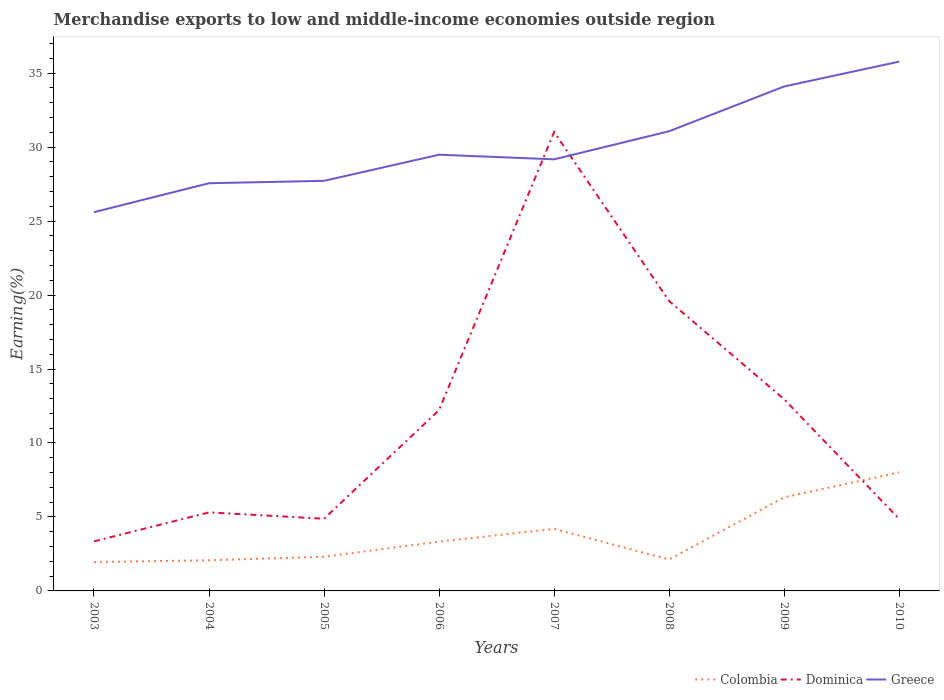How many different coloured lines are there?
Offer a very short reply. 3. Is the number of lines equal to the number of legend labels?
Your response must be concise. Yes. Across all years, what is the maximum percentage of amount earned from merchandise exports in Colombia?
Offer a very short reply. 1.95. In which year was the percentage of amount earned from merchandise exports in Colombia maximum?
Provide a short and direct response. 2003. What is the total percentage of amount earned from merchandise exports in Dominica in the graph?
Keep it short and to the point. -27.67. What is the difference between the highest and the second highest percentage of amount earned from merchandise exports in Greece?
Offer a terse response. 10.18. What is the difference between the highest and the lowest percentage of amount earned from merchandise exports in Colombia?
Your answer should be compact. 3. Is the percentage of amount earned from merchandise exports in Dominica strictly greater than the percentage of amount earned from merchandise exports in Greece over the years?
Provide a succinct answer. No. Are the values on the major ticks of Y-axis written in scientific E-notation?
Your answer should be compact. No. Does the graph contain any zero values?
Your response must be concise. No. Where does the legend appear in the graph?
Make the answer very short. Bottom right. How many legend labels are there?
Keep it short and to the point. 3. How are the legend labels stacked?
Make the answer very short. Horizontal. What is the title of the graph?
Your answer should be very brief. Merchandise exports to low and middle-income economies outside region. What is the label or title of the Y-axis?
Provide a succinct answer. Earning(%). What is the Earning(%) of Colombia in 2003?
Offer a very short reply. 1.95. What is the Earning(%) of Dominica in 2003?
Provide a succinct answer. 3.35. What is the Earning(%) in Greece in 2003?
Provide a short and direct response. 25.6. What is the Earning(%) in Colombia in 2004?
Keep it short and to the point. 2.07. What is the Earning(%) in Dominica in 2004?
Your answer should be compact. 5.31. What is the Earning(%) in Greece in 2004?
Keep it short and to the point. 27.56. What is the Earning(%) in Colombia in 2005?
Your answer should be compact. 2.31. What is the Earning(%) in Dominica in 2005?
Provide a succinct answer. 4.88. What is the Earning(%) in Greece in 2005?
Ensure brevity in your answer.  27.72. What is the Earning(%) of Colombia in 2006?
Offer a very short reply. 3.33. What is the Earning(%) of Dominica in 2006?
Offer a terse response. 12.23. What is the Earning(%) of Greece in 2006?
Provide a succinct answer. 29.48. What is the Earning(%) in Colombia in 2007?
Your answer should be compact. 4.19. What is the Earning(%) of Dominica in 2007?
Your response must be concise. 31.02. What is the Earning(%) in Greece in 2007?
Offer a terse response. 29.17. What is the Earning(%) in Colombia in 2008?
Your answer should be compact. 2.13. What is the Earning(%) of Dominica in 2008?
Give a very brief answer. 19.59. What is the Earning(%) of Greece in 2008?
Keep it short and to the point. 31.07. What is the Earning(%) of Colombia in 2009?
Your answer should be very brief. 6.33. What is the Earning(%) of Dominica in 2009?
Offer a terse response. 12.95. What is the Earning(%) of Greece in 2009?
Your answer should be very brief. 34.1. What is the Earning(%) of Colombia in 2010?
Your answer should be compact. 8.01. What is the Earning(%) of Dominica in 2010?
Make the answer very short. 4.86. What is the Earning(%) of Greece in 2010?
Provide a succinct answer. 35.78. Across all years, what is the maximum Earning(%) of Colombia?
Your answer should be compact. 8.01. Across all years, what is the maximum Earning(%) in Dominica?
Your response must be concise. 31.02. Across all years, what is the maximum Earning(%) in Greece?
Keep it short and to the point. 35.78. Across all years, what is the minimum Earning(%) in Colombia?
Your response must be concise. 1.95. Across all years, what is the minimum Earning(%) of Dominica?
Make the answer very short. 3.35. Across all years, what is the minimum Earning(%) of Greece?
Ensure brevity in your answer.  25.6. What is the total Earning(%) of Colombia in the graph?
Provide a short and direct response. 30.32. What is the total Earning(%) of Dominica in the graph?
Your answer should be very brief. 94.18. What is the total Earning(%) of Greece in the graph?
Your response must be concise. 240.48. What is the difference between the Earning(%) of Colombia in 2003 and that in 2004?
Offer a terse response. -0.12. What is the difference between the Earning(%) of Dominica in 2003 and that in 2004?
Your answer should be very brief. -1.96. What is the difference between the Earning(%) in Greece in 2003 and that in 2004?
Make the answer very short. -1.96. What is the difference between the Earning(%) of Colombia in 2003 and that in 2005?
Your answer should be compact. -0.36. What is the difference between the Earning(%) in Dominica in 2003 and that in 2005?
Provide a succinct answer. -1.53. What is the difference between the Earning(%) in Greece in 2003 and that in 2005?
Your answer should be compact. -2.12. What is the difference between the Earning(%) in Colombia in 2003 and that in 2006?
Provide a short and direct response. -1.38. What is the difference between the Earning(%) in Dominica in 2003 and that in 2006?
Your answer should be compact. -8.88. What is the difference between the Earning(%) of Greece in 2003 and that in 2006?
Give a very brief answer. -3.88. What is the difference between the Earning(%) of Colombia in 2003 and that in 2007?
Provide a succinct answer. -2.24. What is the difference between the Earning(%) of Dominica in 2003 and that in 2007?
Make the answer very short. -27.67. What is the difference between the Earning(%) of Greece in 2003 and that in 2007?
Your answer should be very brief. -3.57. What is the difference between the Earning(%) in Colombia in 2003 and that in 2008?
Your answer should be compact. -0.18. What is the difference between the Earning(%) in Dominica in 2003 and that in 2008?
Make the answer very short. -16.24. What is the difference between the Earning(%) of Greece in 2003 and that in 2008?
Keep it short and to the point. -5.47. What is the difference between the Earning(%) of Colombia in 2003 and that in 2009?
Your answer should be compact. -4.38. What is the difference between the Earning(%) of Dominica in 2003 and that in 2009?
Your answer should be very brief. -9.61. What is the difference between the Earning(%) of Greece in 2003 and that in 2009?
Your answer should be very brief. -8.5. What is the difference between the Earning(%) of Colombia in 2003 and that in 2010?
Make the answer very short. -6.06. What is the difference between the Earning(%) of Dominica in 2003 and that in 2010?
Make the answer very short. -1.52. What is the difference between the Earning(%) in Greece in 2003 and that in 2010?
Your answer should be very brief. -10.18. What is the difference between the Earning(%) in Colombia in 2004 and that in 2005?
Give a very brief answer. -0.24. What is the difference between the Earning(%) of Dominica in 2004 and that in 2005?
Make the answer very short. 0.43. What is the difference between the Earning(%) of Greece in 2004 and that in 2005?
Your response must be concise. -0.16. What is the difference between the Earning(%) in Colombia in 2004 and that in 2006?
Your answer should be compact. -1.26. What is the difference between the Earning(%) of Dominica in 2004 and that in 2006?
Your answer should be compact. -6.92. What is the difference between the Earning(%) in Greece in 2004 and that in 2006?
Give a very brief answer. -1.93. What is the difference between the Earning(%) in Colombia in 2004 and that in 2007?
Your response must be concise. -2.12. What is the difference between the Earning(%) of Dominica in 2004 and that in 2007?
Your answer should be compact. -25.71. What is the difference between the Earning(%) of Greece in 2004 and that in 2007?
Keep it short and to the point. -1.62. What is the difference between the Earning(%) in Colombia in 2004 and that in 2008?
Give a very brief answer. -0.06. What is the difference between the Earning(%) in Dominica in 2004 and that in 2008?
Your answer should be compact. -14.28. What is the difference between the Earning(%) of Greece in 2004 and that in 2008?
Keep it short and to the point. -3.51. What is the difference between the Earning(%) in Colombia in 2004 and that in 2009?
Provide a succinct answer. -4.26. What is the difference between the Earning(%) of Dominica in 2004 and that in 2009?
Provide a succinct answer. -7.64. What is the difference between the Earning(%) in Greece in 2004 and that in 2009?
Provide a succinct answer. -6.54. What is the difference between the Earning(%) of Colombia in 2004 and that in 2010?
Offer a terse response. -5.94. What is the difference between the Earning(%) in Dominica in 2004 and that in 2010?
Make the answer very short. 0.45. What is the difference between the Earning(%) in Greece in 2004 and that in 2010?
Ensure brevity in your answer.  -8.22. What is the difference between the Earning(%) of Colombia in 2005 and that in 2006?
Keep it short and to the point. -1.02. What is the difference between the Earning(%) in Dominica in 2005 and that in 2006?
Your answer should be very brief. -7.35. What is the difference between the Earning(%) in Greece in 2005 and that in 2006?
Offer a very short reply. -1.77. What is the difference between the Earning(%) of Colombia in 2005 and that in 2007?
Ensure brevity in your answer.  -1.88. What is the difference between the Earning(%) of Dominica in 2005 and that in 2007?
Your answer should be very brief. -26.14. What is the difference between the Earning(%) of Greece in 2005 and that in 2007?
Provide a short and direct response. -1.45. What is the difference between the Earning(%) in Colombia in 2005 and that in 2008?
Ensure brevity in your answer.  0.18. What is the difference between the Earning(%) in Dominica in 2005 and that in 2008?
Provide a succinct answer. -14.71. What is the difference between the Earning(%) of Greece in 2005 and that in 2008?
Your answer should be compact. -3.35. What is the difference between the Earning(%) of Colombia in 2005 and that in 2009?
Provide a short and direct response. -4.02. What is the difference between the Earning(%) of Dominica in 2005 and that in 2009?
Offer a terse response. -8.07. What is the difference between the Earning(%) of Greece in 2005 and that in 2009?
Give a very brief answer. -6.38. What is the difference between the Earning(%) of Colombia in 2005 and that in 2010?
Offer a terse response. -5.7. What is the difference between the Earning(%) of Dominica in 2005 and that in 2010?
Your answer should be compact. 0.02. What is the difference between the Earning(%) in Greece in 2005 and that in 2010?
Your answer should be very brief. -8.06. What is the difference between the Earning(%) of Colombia in 2006 and that in 2007?
Keep it short and to the point. -0.86. What is the difference between the Earning(%) in Dominica in 2006 and that in 2007?
Make the answer very short. -18.79. What is the difference between the Earning(%) of Greece in 2006 and that in 2007?
Offer a terse response. 0.31. What is the difference between the Earning(%) of Colombia in 2006 and that in 2008?
Your answer should be very brief. 1.2. What is the difference between the Earning(%) of Dominica in 2006 and that in 2008?
Your answer should be compact. -7.36. What is the difference between the Earning(%) of Greece in 2006 and that in 2008?
Your answer should be compact. -1.59. What is the difference between the Earning(%) of Colombia in 2006 and that in 2009?
Give a very brief answer. -3. What is the difference between the Earning(%) in Dominica in 2006 and that in 2009?
Provide a short and direct response. -0.73. What is the difference between the Earning(%) of Greece in 2006 and that in 2009?
Offer a very short reply. -4.61. What is the difference between the Earning(%) in Colombia in 2006 and that in 2010?
Provide a succinct answer. -4.68. What is the difference between the Earning(%) of Dominica in 2006 and that in 2010?
Your answer should be compact. 7.36. What is the difference between the Earning(%) in Greece in 2006 and that in 2010?
Keep it short and to the point. -6.29. What is the difference between the Earning(%) of Colombia in 2007 and that in 2008?
Provide a short and direct response. 2.06. What is the difference between the Earning(%) in Dominica in 2007 and that in 2008?
Make the answer very short. 11.43. What is the difference between the Earning(%) in Greece in 2007 and that in 2008?
Keep it short and to the point. -1.9. What is the difference between the Earning(%) in Colombia in 2007 and that in 2009?
Provide a short and direct response. -2.14. What is the difference between the Earning(%) in Dominica in 2007 and that in 2009?
Provide a succinct answer. 18.06. What is the difference between the Earning(%) in Greece in 2007 and that in 2009?
Provide a short and direct response. -4.93. What is the difference between the Earning(%) of Colombia in 2007 and that in 2010?
Ensure brevity in your answer.  -3.82. What is the difference between the Earning(%) of Dominica in 2007 and that in 2010?
Keep it short and to the point. 26.15. What is the difference between the Earning(%) in Greece in 2007 and that in 2010?
Offer a very short reply. -6.61. What is the difference between the Earning(%) of Colombia in 2008 and that in 2009?
Provide a short and direct response. -4.2. What is the difference between the Earning(%) of Dominica in 2008 and that in 2009?
Offer a very short reply. 6.64. What is the difference between the Earning(%) in Greece in 2008 and that in 2009?
Ensure brevity in your answer.  -3.03. What is the difference between the Earning(%) in Colombia in 2008 and that in 2010?
Ensure brevity in your answer.  -5.88. What is the difference between the Earning(%) of Dominica in 2008 and that in 2010?
Give a very brief answer. 14.73. What is the difference between the Earning(%) in Greece in 2008 and that in 2010?
Your answer should be compact. -4.71. What is the difference between the Earning(%) of Colombia in 2009 and that in 2010?
Your answer should be very brief. -1.68. What is the difference between the Earning(%) in Dominica in 2009 and that in 2010?
Offer a very short reply. 8.09. What is the difference between the Earning(%) of Greece in 2009 and that in 2010?
Offer a very short reply. -1.68. What is the difference between the Earning(%) in Colombia in 2003 and the Earning(%) in Dominica in 2004?
Make the answer very short. -3.36. What is the difference between the Earning(%) in Colombia in 2003 and the Earning(%) in Greece in 2004?
Offer a very short reply. -25.61. What is the difference between the Earning(%) in Dominica in 2003 and the Earning(%) in Greece in 2004?
Your answer should be very brief. -24.21. What is the difference between the Earning(%) in Colombia in 2003 and the Earning(%) in Dominica in 2005?
Offer a very short reply. -2.93. What is the difference between the Earning(%) of Colombia in 2003 and the Earning(%) of Greece in 2005?
Provide a short and direct response. -25.77. What is the difference between the Earning(%) of Dominica in 2003 and the Earning(%) of Greece in 2005?
Your response must be concise. -24.37. What is the difference between the Earning(%) in Colombia in 2003 and the Earning(%) in Dominica in 2006?
Give a very brief answer. -10.28. What is the difference between the Earning(%) in Colombia in 2003 and the Earning(%) in Greece in 2006?
Keep it short and to the point. -27.53. What is the difference between the Earning(%) in Dominica in 2003 and the Earning(%) in Greece in 2006?
Give a very brief answer. -26.14. What is the difference between the Earning(%) of Colombia in 2003 and the Earning(%) of Dominica in 2007?
Offer a terse response. -29.07. What is the difference between the Earning(%) of Colombia in 2003 and the Earning(%) of Greece in 2007?
Offer a terse response. -27.22. What is the difference between the Earning(%) of Dominica in 2003 and the Earning(%) of Greece in 2007?
Offer a terse response. -25.83. What is the difference between the Earning(%) of Colombia in 2003 and the Earning(%) of Dominica in 2008?
Ensure brevity in your answer.  -17.64. What is the difference between the Earning(%) in Colombia in 2003 and the Earning(%) in Greece in 2008?
Keep it short and to the point. -29.12. What is the difference between the Earning(%) of Dominica in 2003 and the Earning(%) of Greece in 2008?
Your answer should be very brief. -27.72. What is the difference between the Earning(%) in Colombia in 2003 and the Earning(%) in Dominica in 2009?
Offer a terse response. -11. What is the difference between the Earning(%) of Colombia in 2003 and the Earning(%) of Greece in 2009?
Make the answer very short. -32.15. What is the difference between the Earning(%) in Dominica in 2003 and the Earning(%) in Greece in 2009?
Your answer should be very brief. -30.75. What is the difference between the Earning(%) in Colombia in 2003 and the Earning(%) in Dominica in 2010?
Your response must be concise. -2.91. What is the difference between the Earning(%) in Colombia in 2003 and the Earning(%) in Greece in 2010?
Give a very brief answer. -33.83. What is the difference between the Earning(%) of Dominica in 2003 and the Earning(%) of Greece in 2010?
Ensure brevity in your answer.  -32.43. What is the difference between the Earning(%) of Colombia in 2004 and the Earning(%) of Dominica in 2005?
Offer a very short reply. -2.81. What is the difference between the Earning(%) of Colombia in 2004 and the Earning(%) of Greece in 2005?
Your response must be concise. -25.65. What is the difference between the Earning(%) of Dominica in 2004 and the Earning(%) of Greece in 2005?
Your answer should be compact. -22.41. What is the difference between the Earning(%) of Colombia in 2004 and the Earning(%) of Dominica in 2006?
Provide a short and direct response. -10.15. What is the difference between the Earning(%) of Colombia in 2004 and the Earning(%) of Greece in 2006?
Keep it short and to the point. -27.41. What is the difference between the Earning(%) of Dominica in 2004 and the Earning(%) of Greece in 2006?
Offer a terse response. -24.18. What is the difference between the Earning(%) of Colombia in 2004 and the Earning(%) of Dominica in 2007?
Make the answer very short. -28.95. What is the difference between the Earning(%) in Colombia in 2004 and the Earning(%) in Greece in 2007?
Provide a succinct answer. -27.1. What is the difference between the Earning(%) of Dominica in 2004 and the Earning(%) of Greece in 2007?
Your response must be concise. -23.86. What is the difference between the Earning(%) in Colombia in 2004 and the Earning(%) in Dominica in 2008?
Keep it short and to the point. -17.52. What is the difference between the Earning(%) of Colombia in 2004 and the Earning(%) of Greece in 2008?
Give a very brief answer. -29. What is the difference between the Earning(%) of Dominica in 2004 and the Earning(%) of Greece in 2008?
Make the answer very short. -25.76. What is the difference between the Earning(%) in Colombia in 2004 and the Earning(%) in Dominica in 2009?
Offer a very short reply. -10.88. What is the difference between the Earning(%) of Colombia in 2004 and the Earning(%) of Greece in 2009?
Keep it short and to the point. -32.03. What is the difference between the Earning(%) of Dominica in 2004 and the Earning(%) of Greece in 2009?
Your answer should be very brief. -28.79. What is the difference between the Earning(%) in Colombia in 2004 and the Earning(%) in Dominica in 2010?
Offer a very short reply. -2.79. What is the difference between the Earning(%) of Colombia in 2004 and the Earning(%) of Greece in 2010?
Ensure brevity in your answer.  -33.71. What is the difference between the Earning(%) in Dominica in 2004 and the Earning(%) in Greece in 2010?
Your answer should be very brief. -30.47. What is the difference between the Earning(%) of Colombia in 2005 and the Earning(%) of Dominica in 2006?
Offer a terse response. -9.92. What is the difference between the Earning(%) in Colombia in 2005 and the Earning(%) in Greece in 2006?
Offer a terse response. -27.18. What is the difference between the Earning(%) in Dominica in 2005 and the Earning(%) in Greece in 2006?
Make the answer very short. -24.61. What is the difference between the Earning(%) of Colombia in 2005 and the Earning(%) of Dominica in 2007?
Ensure brevity in your answer.  -28.71. What is the difference between the Earning(%) of Colombia in 2005 and the Earning(%) of Greece in 2007?
Provide a short and direct response. -26.86. What is the difference between the Earning(%) in Dominica in 2005 and the Earning(%) in Greece in 2007?
Ensure brevity in your answer.  -24.29. What is the difference between the Earning(%) in Colombia in 2005 and the Earning(%) in Dominica in 2008?
Keep it short and to the point. -17.28. What is the difference between the Earning(%) of Colombia in 2005 and the Earning(%) of Greece in 2008?
Your answer should be compact. -28.76. What is the difference between the Earning(%) in Dominica in 2005 and the Earning(%) in Greece in 2008?
Your answer should be compact. -26.19. What is the difference between the Earning(%) of Colombia in 2005 and the Earning(%) of Dominica in 2009?
Make the answer very short. -10.64. What is the difference between the Earning(%) in Colombia in 2005 and the Earning(%) in Greece in 2009?
Your response must be concise. -31.79. What is the difference between the Earning(%) in Dominica in 2005 and the Earning(%) in Greece in 2009?
Give a very brief answer. -29.22. What is the difference between the Earning(%) of Colombia in 2005 and the Earning(%) of Dominica in 2010?
Your answer should be compact. -2.55. What is the difference between the Earning(%) of Colombia in 2005 and the Earning(%) of Greece in 2010?
Make the answer very short. -33.47. What is the difference between the Earning(%) of Dominica in 2005 and the Earning(%) of Greece in 2010?
Your answer should be compact. -30.9. What is the difference between the Earning(%) in Colombia in 2006 and the Earning(%) in Dominica in 2007?
Offer a very short reply. -27.69. What is the difference between the Earning(%) in Colombia in 2006 and the Earning(%) in Greece in 2007?
Offer a terse response. -25.84. What is the difference between the Earning(%) in Dominica in 2006 and the Earning(%) in Greece in 2007?
Make the answer very short. -16.95. What is the difference between the Earning(%) in Colombia in 2006 and the Earning(%) in Dominica in 2008?
Offer a terse response. -16.26. What is the difference between the Earning(%) in Colombia in 2006 and the Earning(%) in Greece in 2008?
Keep it short and to the point. -27.74. What is the difference between the Earning(%) in Dominica in 2006 and the Earning(%) in Greece in 2008?
Your answer should be compact. -18.85. What is the difference between the Earning(%) in Colombia in 2006 and the Earning(%) in Dominica in 2009?
Provide a succinct answer. -9.62. What is the difference between the Earning(%) in Colombia in 2006 and the Earning(%) in Greece in 2009?
Your answer should be compact. -30.77. What is the difference between the Earning(%) of Dominica in 2006 and the Earning(%) of Greece in 2009?
Provide a succinct answer. -21.87. What is the difference between the Earning(%) in Colombia in 2006 and the Earning(%) in Dominica in 2010?
Your answer should be compact. -1.53. What is the difference between the Earning(%) in Colombia in 2006 and the Earning(%) in Greece in 2010?
Your response must be concise. -32.45. What is the difference between the Earning(%) in Dominica in 2006 and the Earning(%) in Greece in 2010?
Give a very brief answer. -23.55. What is the difference between the Earning(%) in Colombia in 2007 and the Earning(%) in Dominica in 2008?
Your answer should be compact. -15.4. What is the difference between the Earning(%) in Colombia in 2007 and the Earning(%) in Greece in 2008?
Offer a terse response. -26.88. What is the difference between the Earning(%) in Dominica in 2007 and the Earning(%) in Greece in 2008?
Give a very brief answer. -0.05. What is the difference between the Earning(%) of Colombia in 2007 and the Earning(%) of Dominica in 2009?
Keep it short and to the point. -8.76. What is the difference between the Earning(%) of Colombia in 2007 and the Earning(%) of Greece in 2009?
Your response must be concise. -29.91. What is the difference between the Earning(%) of Dominica in 2007 and the Earning(%) of Greece in 2009?
Your answer should be very brief. -3.08. What is the difference between the Earning(%) in Colombia in 2007 and the Earning(%) in Dominica in 2010?
Offer a terse response. -0.67. What is the difference between the Earning(%) in Colombia in 2007 and the Earning(%) in Greece in 2010?
Make the answer very short. -31.59. What is the difference between the Earning(%) in Dominica in 2007 and the Earning(%) in Greece in 2010?
Provide a short and direct response. -4.76. What is the difference between the Earning(%) in Colombia in 2008 and the Earning(%) in Dominica in 2009?
Offer a very short reply. -10.82. What is the difference between the Earning(%) in Colombia in 2008 and the Earning(%) in Greece in 2009?
Your answer should be compact. -31.97. What is the difference between the Earning(%) of Dominica in 2008 and the Earning(%) of Greece in 2009?
Your response must be concise. -14.51. What is the difference between the Earning(%) in Colombia in 2008 and the Earning(%) in Dominica in 2010?
Offer a very short reply. -2.73. What is the difference between the Earning(%) in Colombia in 2008 and the Earning(%) in Greece in 2010?
Keep it short and to the point. -33.65. What is the difference between the Earning(%) in Dominica in 2008 and the Earning(%) in Greece in 2010?
Offer a terse response. -16.19. What is the difference between the Earning(%) of Colombia in 2009 and the Earning(%) of Dominica in 2010?
Your response must be concise. 1.47. What is the difference between the Earning(%) of Colombia in 2009 and the Earning(%) of Greece in 2010?
Your response must be concise. -29.45. What is the difference between the Earning(%) of Dominica in 2009 and the Earning(%) of Greece in 2010?
Ensure brevity in your answer.  -22.83. What is the average Earning(%) in Colombia per year?
Offer a very short reply. 3.79. What is the average Earning(%) of Dominica per year?
Provide a succinct answer. 11.77. What is the average Earning(%) of Greece per year?
Your answer should be compact. 30.06. In the year 2003, what is the difference between the Earning(%) in Colombia and Earning(%) in Dominica?
Keep it short and to the point. -1.4. In the year 2003, what is the difference between the Earning(%) of Colombia and Earning(%) of Greece?
Provide a succinct answer. -23.65. In the year 2003, what is the difference between the Earning(%) in Dominica and Earning(%) in Greece?
Your response must be concise. -22.25. In the year 2004, what is the difference between the Earning(%) of Colombia and Earning(%) of Dominica?
Keep it short and to the point. -3.24. In the year 2004, what is the difference between the Earning(%) in Colombia and Earning(%) in Greece?
Offer a very short reply. -25.49. In the year 2004, what is the difference between the Earning(%) in Dominica and Earning(%) in Greece?
Provide a succinct answer. -22.25. In the year 2005, what is the difference between the Earning(%) in Colombia and Earning(%) in Dominica?
Your answer should be compact. -2.57. In the year 2005, what is the difference between the Earning(%) in Colombia and Earning(%) in Greece?
Your response must be concise. -25.41. In the year 2005, what is the difference between the Earning(%) in Dominica and Earning(%) in Greece?
Give a very brief answer. -22.84. In the year 2006, what is the difference between the Earning(%) of Colombia and Earning(%) of Dominica?
Ensure brevity in your answer.  -8.89. In the year 2006, what is the difference between the Earning(%) of Colombia and Earning(%) of Greece?
Provide a short and direct response. -26.15. In the year 2006, what is the difference between the Earning(%) of Dominica and Earning(%) of Greece?
Ensure brevity in your answer.  -17.26. In the year 2007, what is the difference between the Earning(%) in Colombia and Earning(%) in Dominica?
Make the answer very short. -26.82. In the year 2007, what is the difference between the Earning(%) of Colombia and Earning(%) of Greece?
Provide a short and direct response. -24.98. In the year 2007, what is the difference between the Earning(%) in Dominica and Earning(%) in Greece?
Offer a very short reply. 1.84. In the year 2008, what is the difference between the Earning(%) in Colombia and Earning(%) in Dominica?
Your answer should be very brief. -17.46. In the year 2008, what is the difference between the Earning(%) in Colombia and Earning(%) in Greece?
Keep it short and to the point. -28.94. In the year 2008, what is the difference between the Earning(%) of Dominica and Earning(%) of Greece?
Your answer should be compact. -11.48. In the year 2009, what is the difference between the Earning(%) in Colombia and Earning(%) in Dominica?
Offer a terse response. -6.62. In the year 2009, what is the difference between the Earning(%) of Colombia and Earning(%) of Greece?
Ensure brevity in your answer.  -27.77. In the year 2009, what is the difference between the Earning(%) in Dominica and Earning(%) in Greece?
Give a very brief answer. -21.15. In the year 2010, what is the difference between the Earning(%) of Colombia and Earning(%) of Dominica?
Keep it short and to the point. 3.15. In the year 2010, what is the difference between the Earning(%) in Colombia and Earning(%) in Greece?
Provide a short and direct response. -27.77. In the year 2010, what is the difference between the Earning(%) of Dominica and Earning(%) of Greece?
Keep it short and to the point. -30.92. What is the ratio of the Earning(%) of Colombia in 2003 to that in 2004?
Offer a terse response. 0.94. What is the ratio of the Earning(%) in Dominica in 2003 to that in 2004?
Your response must be concise. 0.63. What is the ratio of the Earning(%) of Greece in 2003 to that in 2004?
Make the answer very short. 0.93. What is the ratio of the Earning(%) in Colombia in 2003 to that in 2005?
Your answer should be compact. 0.84. What is the ratio of the Earning(%) in Dominica in 2003 to that in 2005?
Your answer should be very brief. 0.69. What is the ratio of the Earning(%) of Greece in 2003 to that in 2005?
Give a very brief answer. 0.92. What is the ratio of the Earning(%) of Colombia in 2003 to that in 2006?
Your answer should be compact. 0.59. What is the ratio of the Earning(%) of Dominica in 2003 to that in 2006?
Offer a terse response. 0.27. What is the ratio of the Earning(%) in Greece in 2003 to that in 2006?
Your response must be concise. 0.87. What is the ratio of the Earning(%) in Colombia in 2003 to that in 2007?
Provide a short and direct response. 0.47. What is the ratio of the Earning(%) in Dominica in 2003 to that in 2007?
Ensure brevity in your answer.  0.11. What is the ratio of the Earning(%) in Greece in 2003 to that in 2007?
Your answer should be compact. 0.88. What is the ratio of the Earning(%) of Colombia in 2003 to that in 2008?
Offer a very short reply. 0.92. What is the ratio of the Earning(%) in Dominica in 2003 to that in 2008?
Offer a terse response. 0.17. What is the ratio of the Earning(%) of Greece in 2003 to that in 2008?
Your response must be concise. 0.82. What is the ratio of the Earning(%) in Colombia in 2003 to that in 2009?
Provide a short and direct response. 0.31. What is the ratio of the Earning(%) of Dominica in 2003 to that in 2009?
Keep it short and to the point. 0.26. What is the ratio of the Earning(%) in Greece in 2003 to that in 2009?
Provide a succinct answer. 0.75. What is the ratio of the Earning(%) in Colombia in 2003 to that in 2010?
Provide a short and direct response. 0.24. What is the ratio of the Earning(%) in Dominica in 2003 to that in 2010?
Keep it short and to the point. 0.69. What is the ratio of the Earning(%) of Greece in 2003 to that in 2010?
Make the answer very short. 0.72. What is the ratio of the Earning(%) of Colombia in 2004 to that in 2005?
Your response must be concise. 0.9. What is the ratio of the Earning(%) of Dominica in 2004 to that in 2005?
Your answer should be very brief. 1.09. What is the ratio of the Earning(%) in Greece in 2004 to that in 2005?
Make the answer very short. 0.99. What is the ratio of the Earning(%) of Colombia in 2004 to that in 2006?
Keep it short and to the point. 0.62. What is the ratio of the Earning(%) in Dominica in 2004 to that in 2006?
Your answer should be compact. 0.43. What is the ratio of the Earning(%) in Greece in 2004 to that in 2006?
Keep it short and to the point. 0.93. What is the ratio of the Earning(%) of Colombia in 2004 to that in 2007?
Offer a very short reply. 0.49. What is the ratio of the Earning(%) of Dominica in 2004 to that in 2007?
Your answer should be compact. 0.17. What is the ratio of the Earning(%) in Greece in 2004 to that in 2007?
Provide a succinct answer. 0.94. What is the ratio of the Earning(%) in Colombia in 2004 to that in 2008?
Offer a terse response. 0.97. What is the ratio of the Earning(%) in Dominica in 2004 to that in 2008?
Keep it short and to the point. 0.27. What is the ratio of the Earning(%) of Greece in 2004 to that in 2008?
Your answer should be compact. 0.89. What is the ratio of the Earning(%) in Colombia in 2004 to that in 2009?
Provide a short and direct response. 0.33. What is the ratio of the Earning(%) in Dominica in 2004 to that in 2009?
Provide a short and direct response. 0.41. What is the ratio of the Earning(%) in Greece in 2004 to that in 2009?
Ensure brevity in your answer.  0.81. What is the ratio of the Earning(%) of Colombia in 2004 to that in 2010?
Make the answer very short. 0.26. What is the ratio of the Earning(%) in Dominica in 2004 to that in 2010?
Offer a terse response. 1.09. What is the ratio of the Earning(%) of Greece in 2004 to that in 2010?
Your answer should be very brief. 0.77. What is the ratio of the Earning(%) of Colombia in 2005 to that in 2006?
Your answer should be very brief. 0.69. What is the ratio of the Earning(%) of Dominica in 2005 to that in 2006?
Your response must be concise. 0.4. What is the ratio of the Earning(%) of Greece in 2005 to that in 2006?
Your response must be concise. 0.94. What is the ratio of the Earning(%) of Colombia in 2005 to that in 2007?
Your answer should be compact. 0.55. What is the ratio of the Earning(%) of Dominica in 2005 to that in 2007?
Provide a succinct answer. 0.16. What is the ratio of the Earning(%) in Greece in 2005 to that in 2007?
Offer a terse response. 0.95. What is the ratio of the Earning(%) in Colombia in 2005 to that in 2008?
Offer a very short reply. 1.08. What is the ratio of the Earning(%) of Dominica in 2005 to that in 2008?
Offer a terse response. 0.25. What is the ratio of the Earning(%) of Greece in 2005 to that in 2008?
Provide a short and direct response. 0.89. What is the ratio of the Earning(%) of Colombia in 2005 to that in 2009?
Keep it short and to the point. 0.36. What is the ratio of the Earning(%) of Dominica in 2005 to that in 2009?
Make the answer very short. 0.38. What is the ratio of the Earning(%) of Greece in 2005 to that in 2009?
Keep it short and to the point. 0.81. What is the ratio of the Earning(%) in Colombia in 2005 to that in 2010?
Offer a terse response. 0.29. What is the ratio of the Earning(%) in Greece in 2005 to that in 2010?
Your response must be concise. 0.77. What is the ratio of the Earning(%) in Colombia in 2006 to that in 2007?
Offer a very short reply. 0.79. What is the ratio of the Earning(%) in Dominica in 2006 to that in 2007?
Offer a very short reply. 0.39. What is the ratio of the Earning(%) of Greece in 2006 to that in 2007?
Offer a terse response. 1.01. What is the ratio of the Earning(%) in Colombia in 2006 to that in 2008?
Your response must be concise. 1.56. What is the ratio of the Earning(%) of Dominica in 2006 to that in 2008?
Provide a succinct answer. 0.62. What is the ratio of the Earning(%) in Greece in 2006 to that in 2008?
Provide a short and direct response. 0.95. What is the ratio of the Earning(%) in Colombia in 2006 to that in 2009?
Your answer should be compact. 0.53. What is the ratio of the Earning(%) of Dominica in 2006 to that in 2009?
Your answer should be very brief. 0.94. What is the ratio of the Earning(%) in Greece in 2006 to that in 2009?
Offer a terse response. 0.86. What is the ratio of the Earning(%) of Colombia in 2006 to that in 2010?
Offer a terse response. 0.42. What is the ratio of the Earning(%) in Dominica in 2006 to that in 2010?
Your answer should be very brief. 2.51. What is the ratio of the Earning(%) in Greece in 2006 to that in 2010?
Keep it short and to the point. 0.82. What is the ratio of the Earning(%) of Colombia in 2007 to that in 2008?
Keep it short and to the point. 1.97. What is the ratio of the Earning(%) of Dominica in 2007 to that in 2008?
Your answer should be compact. 1.58. What is the ratio of the Earning(%) of Greece in 2007 to that in 2008?
Give a very brief answer. 0.94. What is the ratio of the Earning(%) in Colombia in 2007 to that in 2009?
Your answer should be very brief. 0.66. What is the ratio of the Earning(%) in Dominica in 2007 to that in 2009?
Your response must be concise. 2.39. What is the ratio of the Earning(%) of Greece in 2007 to that in 2009?
Provide a succinct answer. 0.86. What is the ratio of the Earning(%) in Colombia in 2007 to that in 2010?
Your response must be concise. 0.52. What is the ratio of the Earning(%) in Dominica in 2007 to that in 2010?
Provide a short and direct response. 6.38. What is the ratio of the Earning(%) in Greece in 2007 to that in 2010?
Ensure brevity in your answer.  0.82. What is the ratio of the Earning(%) in Colombia in 2008 to that in 2009?
Give a very brief answer. 0.34. What is the ratio of the Earning(%) in Dominica in 2008 to that in 2009?
Your response must be concise. 1.51. What is the ratio of the Earning(%) in Greece in 2008 to that in 2009?
Offer a terse response. 0.91. What is the ratio of the Earning(%) of Colombia in 2008 to that in 2010?
Offer a terse response. 0.27. What is the ratio of the Earning(%) in Dominica in 2008 to that in 2010?
Your answer should be compact. 4.03. What is the ratio of the Earning(%) in Greece in 2008 to that in 2010?
Give a very brief answer. 0.87. What is the ratio of the Earning(%) in Colombia in 2009 to that in 2010?
Offer a terse response. 0.79. What is the ratio of the Earning(%) of Dominica in 2009 to that in 2010?
Keep it short and to the point. 2.66. What is the ratio of the Earning(%) of Greece in 2009 to that in 2010?
Offer a terse response. 0.95. What is the difference between the highest and the second highest Earning(%) in Colombia?
Provide a succinct answer. 1.68. What is the difference between the highest and the second highest Earning(%) of Dominica?
Give a very brief answer. 11.43. What is the difference between the highest and the second highest Earning(%) of Greece?
Offer a terse response. 1.68. What is the difference between the highest and the lowest Earning(%) of Colombia?
Your answer should be very brief. 6.06. What is the difference between the highest and the lowest Earning(%) in Dominica?
Your answer should be very brief. 27.67. What is the difference between the highest and the lowest Earning(%) in Greece?
Keep it short and to the point. 10.18. 